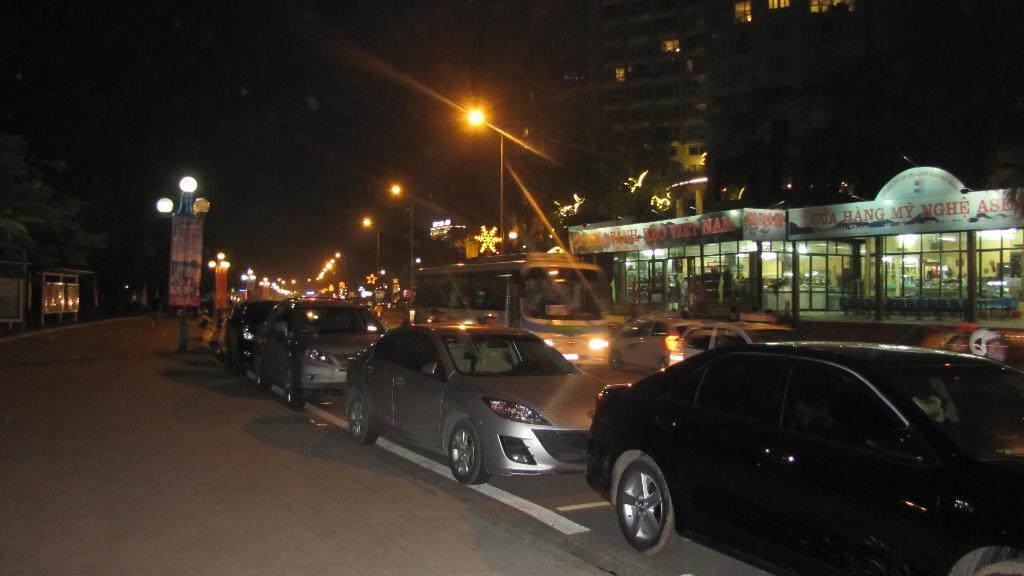Describe this image in one or two sentences. This picture is clicked outside the city. Here, we see many cars and buses are moving on the road. On the right corner of the picture, we see buildings and trees. On either side of the road, we see street lights and at the top of the picture, it is black in color. This picture is clicked in the dark. 